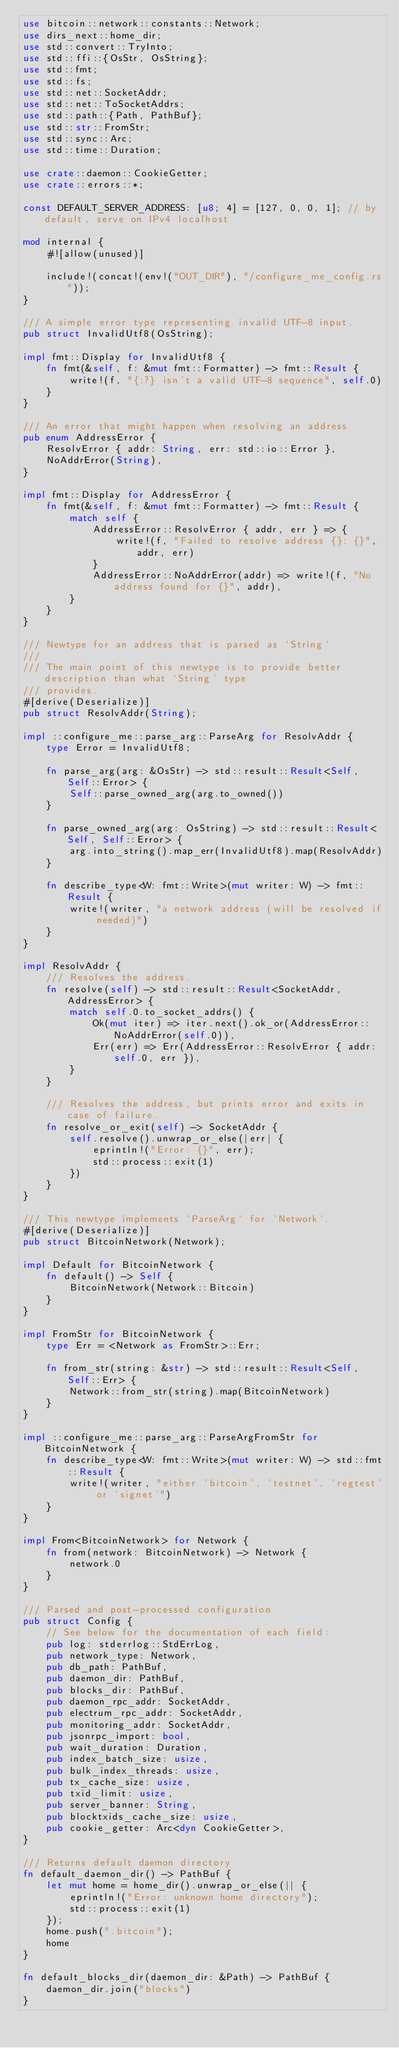Convert code to text. <code><loc_0><loc_0><loc_500><loc_500><_Rust_>use bitcoin::network::constants::Network;
use dirs_next::home_dir;
use std::convert::TryInto;
use std::ffi::{OsStr, OsString};
use std::fmt;
use std::fs;
use std::net::SocketAddr;
use std::net::ToSocketAddrs;
use std::path::{Path, PathBuf};
use std::str::FromStr;
use std::sync::Arc;
use std::time::Duration;

use crate::daemon::CookieGetter;
use crate::errors::*;

const DEFAULT_SERVER_ADDRESS: [u8; 4] = [127, 0, 0, 1]; // by default, serve on IPv4 localhost

mod internal {
    #![allow(unused)]

    include!(concat!(env!("OUT_DIR"), "/configure_me_config.rs"));
}

/// A simple error type representing invalid UTF-8 input.
pub struct InvalidUtf8(OsString);

impl fmt::Display for InvalidUtf8 {
    fn fmt(&self, f: &mut fmt::Formatter) -> fmt::Result {
        write!(f, "{:?} isn't a valid UTF-8 sequence", self.0)
    }
}

/// An error that might happen when resolving an address
pub enum AddressError {
    ResolvError { addr: String, err: std::io::Error },
    NoAddrError(String),
}

impl fmt::Display for AddressError {
    fn fmt(&self, f: &mut fmt::Formatter) -> fmt::Result {
        match self {
            AddressError::ResolvError { addr, err } => {
                write!(f, "Failed to resolve address {}: {}", addr, err)
            }
            AddressError::NoAddrError(addr) => write!(f, "No address found for {}", addr),
        }
    }
}

/// Newtype for an address that is parsed as `String`
///
/// The main point of this newtype is to provide better description than what `String` type
/// provides.
#[derive(Deserialize)]
pub struct ResolvAddr(String);

impl ::configure_me::parse_arg::ParseArg for ResolvAddr {
    type Error = InvalidUtf8;

    fn parse_arg(arg: &OsStr) -> std::result::Result<Self, Self::Error> {
        Self::parse_owned_arg(arg.to_owned())
    }

    fn parse_owned_arg(arg: OsString) -> std::result::Result<Self, Self::Error> {
        arg.into_string().map_err(InvalidUtf8).map(ResolvAddr)
    }

    fn describe_type<W: fmt::Write>(mut writer: W) -> fmt::Result {
        write!(writer, "a network address (will be resolved if needed)")
    }
}

impl ResolvAddr {
    /// Resolves the address.
    fn resolve(self) -> std::result::Result<SocketAddr, AddressError> {
        match self.0.to_socket_addrs() {
            Ok(mut iter) => iter.next().ok_or(AddressError::NoAddrError(self.0)),
            Err(err) => Err(AddressError::ResolvError { addr: self.0, err }),
        }
    }

    /// Resolves the address, but prints error and exits in case of failure.
    fn resolve_or_exit(self) -> SocketAddr {
        self.resolve().unwrap_or_else(|err| {
            eprintln!("Error: {}", err);
            std::process::exit(1)
        })
    }
}

/// This newtype implements `ParseArg` for `Network`.
#[derive(Deserialize)]
pub struct BitcoinNetwork(Network);

impl Default for BitcoinNetwork {
    fn default() -> Self {
        BitcoinNetwork(Network::Bitcoin)
    }
}

impl FromStr for BitcoinNetwork {
    type Err = <Network as FromStr>::Err;

    fn from_str(string: &str) -> std::result::Result<Self, Self::Err> {
        Network::from_str(string).map(BitcoinNetwork)
    }
}

impl ::configure_me::parse_arg::ParseArgFromStr for BitcoinNetwork {
    fn describe_type<W: fmt::Write>(mut writer: W) -> std::fmt::Result {
        write!(writer, "either 'bitcoin', 'testnet', 'regtest' or 'signet'")
    }
}

impl From<BitcoinNetwork> for Network {
    fn from(network: BitcoinNetwork) -> Network {
        network.0
    }
}

/// Parsed and post-processed configuration
pub struct Config {
    // See below for the documentation of each field:
    pub log: stderrlog::StdErrLog,
    pub network_type: Network,
    pub db_path: PathBuf,
    pub daemon_dir: PathBuf,
    pub blocks_dir: PathBuf,
    pub daemon_rpc_addr: SocketAddr,
    pub electrum_rpc_addr: SocketAddr,
    pub monitoring_addr: SocketAddr,
    pub jsonrpc_import: bool,
    pub wait_duration: Duration,
    pub index_batch_size: usize,
    pub bulk_index_threads: usize,
    pub tx_cache_size: usize,
    pub txid_limit: usize,
    pub server_banner: String,
    pub blocktxids_cache_size: usize,
    pub cookie_getter: Arc<dyn CookieGetter>,
}

/// Returns default daemon directory
fn default_daemon_dir() -> PathBuf {
    let mut home = home_dir().unwrap_or_else(|| {
        eprintln!("Error: unknown home directory");
        std::process::exit(1)
    });
    home.push(".bitcoin");
    home
}

fn default_blocks_dir(daemon_dir: &Path) -> PathBuf {
    daemon_dir.join("blocks")
}
</code> 